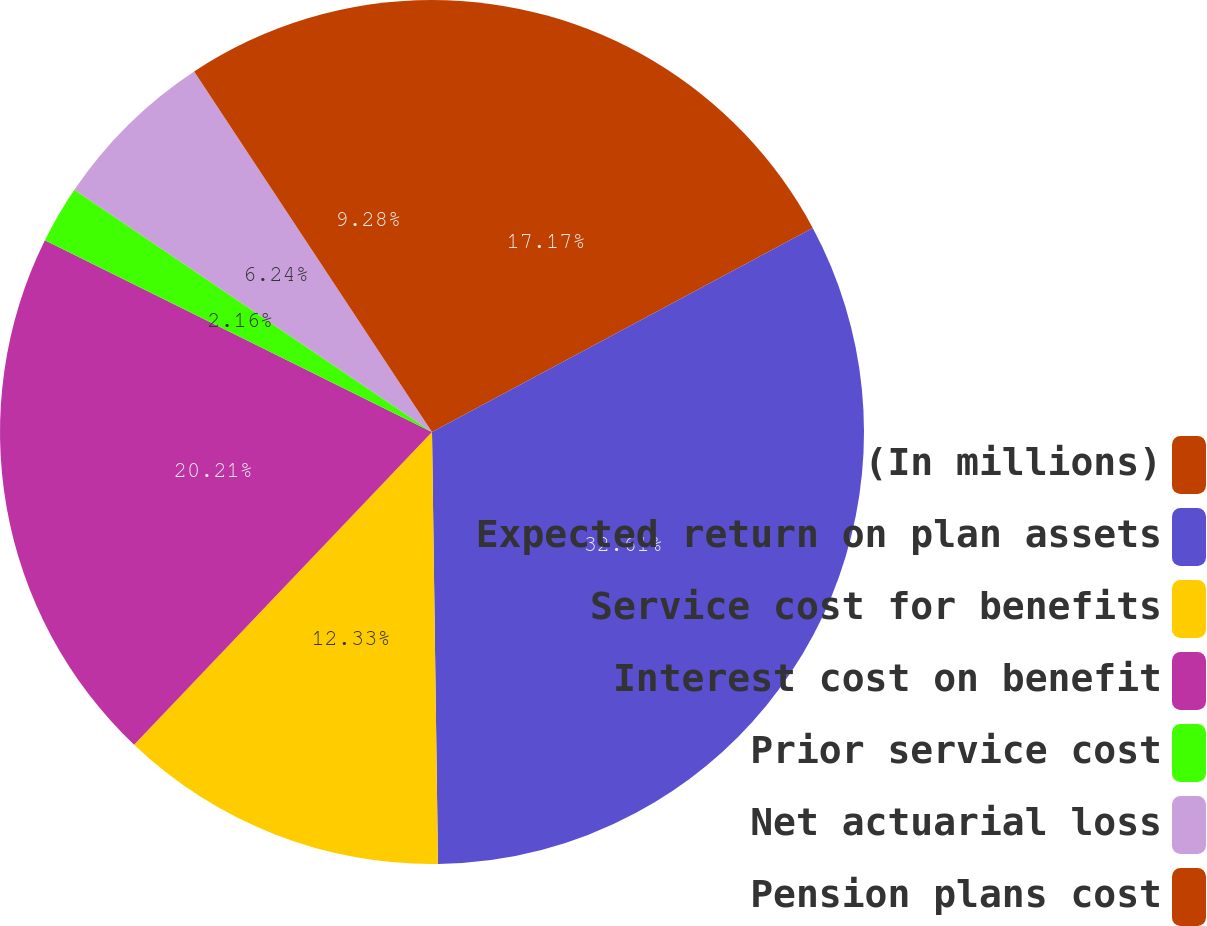Convert chart. <chart><loc_0><loc_0><loc_500><loc_500><pie_chart><fcel>(In millions)<fcel>Expected return on plan assets<fcel>Service cost for benefits<fcel>Interest cost on benefit<fcel>Prior service cost<fcel>Net actuarial loss<fcel>Pension plans cost<nl><fcel>17.17%<fcel>32.61%<fcel>12.33%<fcel>20.21%<fcel>2.16%<fcel>6.24%<fcel>9.28%<nl></chart> 